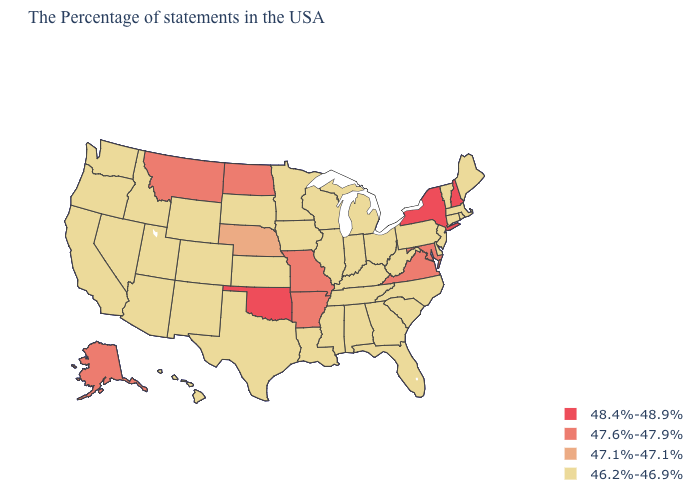Name the states that have a value in the range 48.4%-48.9%?
Concise answer only. New Hampshire, New York, Oklahoma. What is the value of New Jersey?
Be succinct. 46.2%-46.9%. What is the value of Alaska?
Answer briefly. 47.6%-47.9%. Name the states that have a value in the range 47.6%-47.9%?
Short answer required. Maryland, Virginia, Missouri, Arkansas, North Dakota, Montana, Alaska. Name the states that have a value in the range 47.6%-47.9%?
Short answer required. Maryland, Virginia, Missouri, Arkansas, North Dakota, Montana, Alaska. Name the states that have a value in the range 46.2%-46.9%?
Keep it brief. Maine, Massachusetts, Rhode Island, Vermont, Connecticut, New Jersey, Delaware, Pennsylvania, North Carolina, South Carolina, West Virginia, Ohio, Florida, Georgia, Michigan, Kentucky, Indiana, Alabama, Tennessee, Wisconsin, Illinois, Mississippi, Louisiana, Minnesota, Iowa, Kansas, Texas, South Dakota, Wyoming, Colorado, New Mexico, Utah, Arizona, Idaho, Nevada, California, Washington, Oregon, Hawaii. What is the value of Montana?
Be succinct. 47.6%-47.9%. Does Arkansas have the lowest value in the USA?
Quick response, please. No. Name the states that have a value in the range 47.6%-47.9%?
Answer briefly. Maryland, Virginia, Missouri, Arkansas, North Dakota, Montana, Alaska. Name the states that have a value in the range 46.2%-46.9%?
Be succinct. Maine, Massachusetts, Rhode Island, Vermont, Connecticut, New Jersey, Delaware, Pennsylvania, North Carolina, South Carolina, West Virginia, Ohio, Florida, Georgia, Michigan, Kentucky, Indiana, Alabama, Tennessee, Wisconsin, Illinois, Mississippi, Louisiana, Minnesota, Iowa, Kansas, Texas, South Dakota, Wyoming, Colorado, New Mexico, Utah, Arizona, Idaho, Nevada, California, Washington, Oregon, Hawaii. Which states have the highest value in the USA?
Be succinct. New Hampshire, New York, Oklahoma. Name the states that have a value in the range 47.6%-47.9%?
Answer briefly. Maryland, Virginia, Missouri, Arkansas, North Dakota, Montana, Alaska. Does Ohio have a lower value than Oklahoma?
Short answer required. Yes. Name the states that have a value in the range 46.2%-46.9%?
Concise answer only. Maine, Massachusetts, Rhode Island, Vermont, Connecticut, New Jersey, Delaware, Pennsylvania, North Carolina, South Carolina, West Virginia, Ohio, Florida, Georgia, Michigan, Kentucky, Indiana, Alabama, Tennessee, Wisconsin, Illinois, Mississippi, Louisiana, Minnesota, Iowa, Kansas, Texas, South Dakota, Wyoming, Colorado, New Mexico, Utah, Arizona, Idaho, Nevada, California, Washington, Oregon, Hawaii. What is the value of Idaho?
Give a very brief answer. 46.2%-46.9%. 